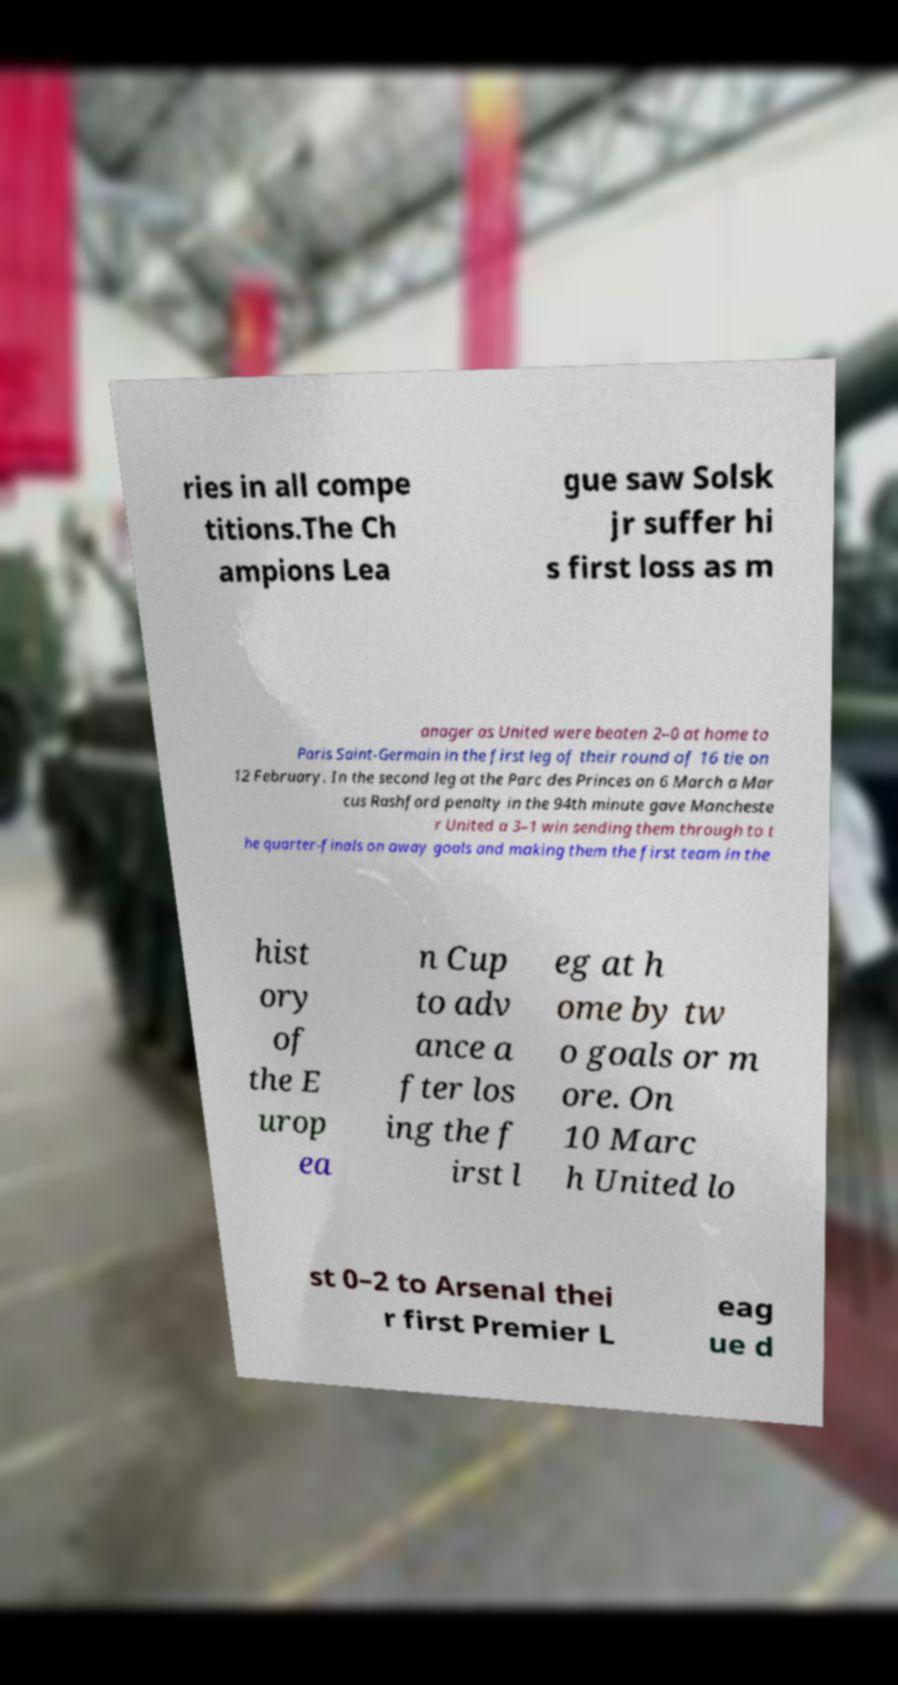Please read and relay the text visible in this image. What does it say? ries in all compe titions.The Ch ampions Lea gue saw Solsk jr suffer hi s first loss as m anager as United were beaten 2–0 at home to Paris Saint-Germain in the first leg of their round of 16 tie on 12 February. In the second leg at the Parc des Princes on 6 March a Mar cus Rashford penalty in the 94th minute gave Mancheste r United a 3–1 win sending them through to t he quarter-finals on away goals and making them the first team in the hist ory of the E urop ea n Cup to adv ance a fter los ing the f irst l eg at h ome by tw o goals or m ore. On 10 Marc h United lo st 0–2 to Arsenal thei r first Premier L eag ue d 